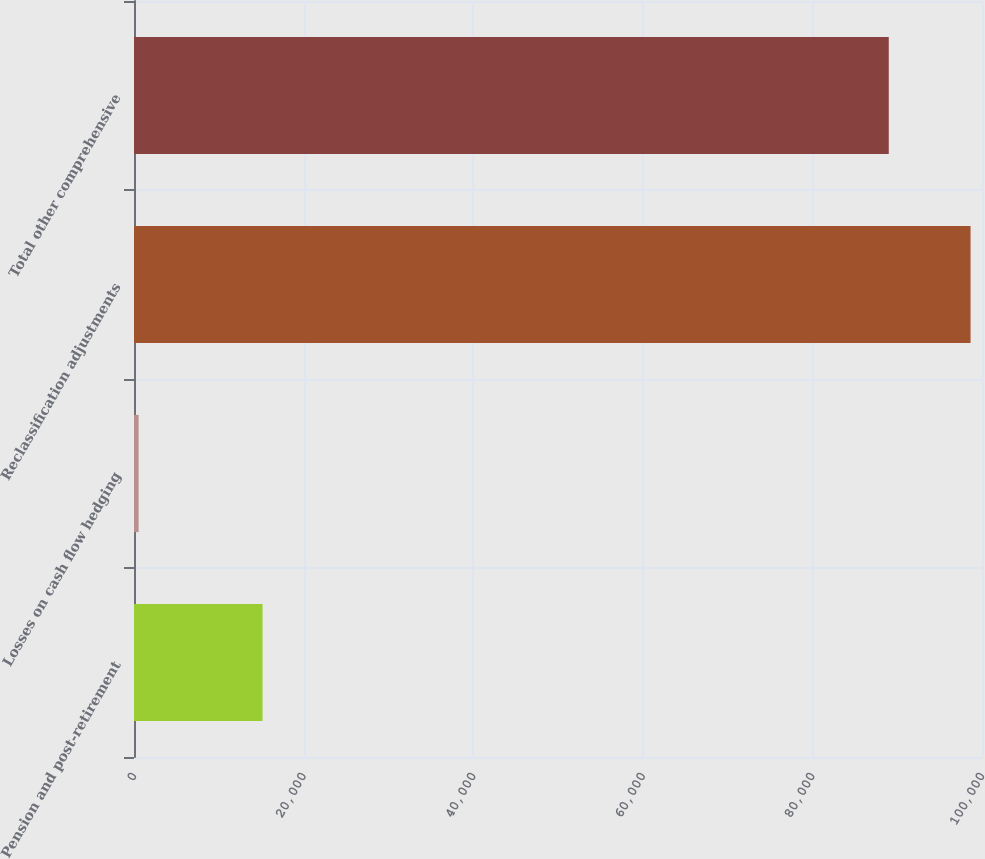<chart> <loc_0><loc_0><loc_500><loc_500><bar_chart><fcel>Pension and post-retirement<fcel>Losses on cash flow hedging<fcel>Reclassification adjustments<fcel>Total other comprehensive<nl><fcel>15159<fcel>543<fcel>98650<fcel>89005<nl></chart> 